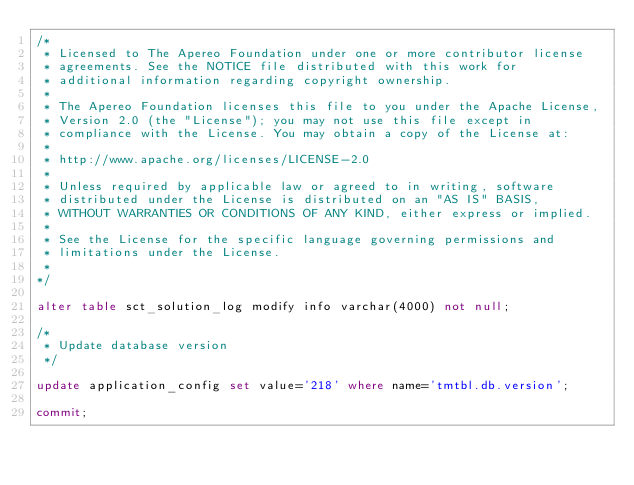Convert code to text. <code><loc_0><loc_0><loc_500><loc_500><_SQL_>/*
 * Licensed to The Apereo Foundation under one or more contributor license
 * agreements. See the NOTICE file distributed with this work for
 * additional information regarding copyright ownership.
 *
 * The Apereo Foundation licenses this file to you under the Apache License,
 * Version 2.0 (the "License"); you may not use this file except in
 * compliance with the License. You may obtain a copy of the License at:
 *
 * http://www.apache.org/licenses/LICENSE-2.0
 *
 * Unless required by applicable law or agreed to in writing, software
 * distributed under the License is distributed on an "AS IS" BASIS,
 * WITHOUT WARRANTIES OR CONDITIONS OF ANY KIND, either express or implied.
 *
 * See the License for the specific language governing permissions and
 * limitations under the License.
 * 
*/

alter table sct_solution_log modify info varchar(4000) not null;

/*
 * Update database version
 */

update application_config set value='218' where name='tmtbl.db.version';

commit;
</code> 